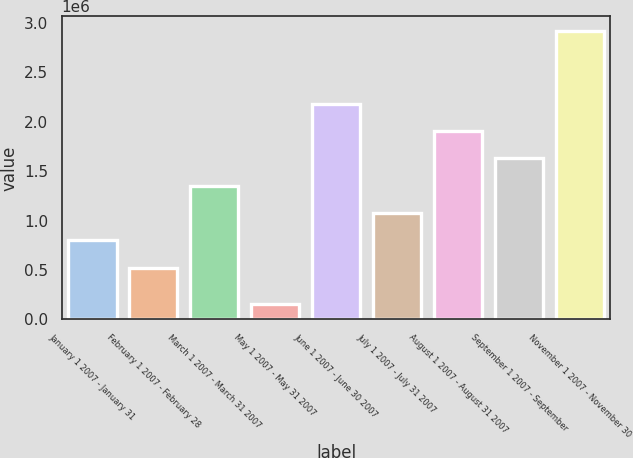Convert chart. <chart><loc_0><loc_0><loc_500><loc_500><bar_chart><fcel>January 1 2007 - January 31<fcel>February 1 2007 - February 28<fcel>March 1 2007 - March 31 2007<fcel>May 1 2007 - May 31 2007<fcel>June 1 2007 - June 30 2007<fcel>July 1 2007 - July 31 2007<fcel>August 1 2007 - August 31 2007<fcel>September 1 2007 - September<fcel>November 1 2007 - November 30<nl><fcel>800438<fcel>523900<fcel>1.35351e+06<fcel>152000<fcel>2.18313e+06<fcel>1.07698e+06<fcel>1.90659e+06<fcel>1.63005e+06<fcel>2.91738e+06<nl></chart> 